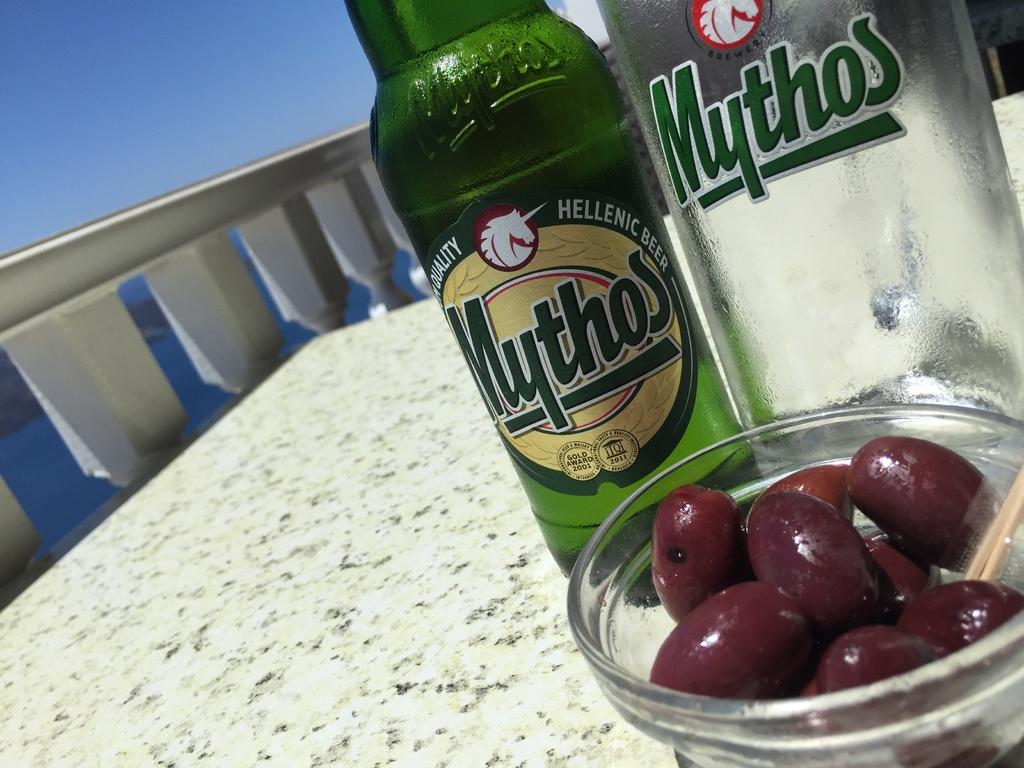What type of furniture is present in the image? There is a table in the image. What type of containers can be seen in the image? There are bottles in the image. What type of dishware is present in the image? There is a bowl in the image. How does the beggar feel about the comfort provided by the table in the image? There is no beggar present in the image, so it is not possible to determine their feelings about the table. 